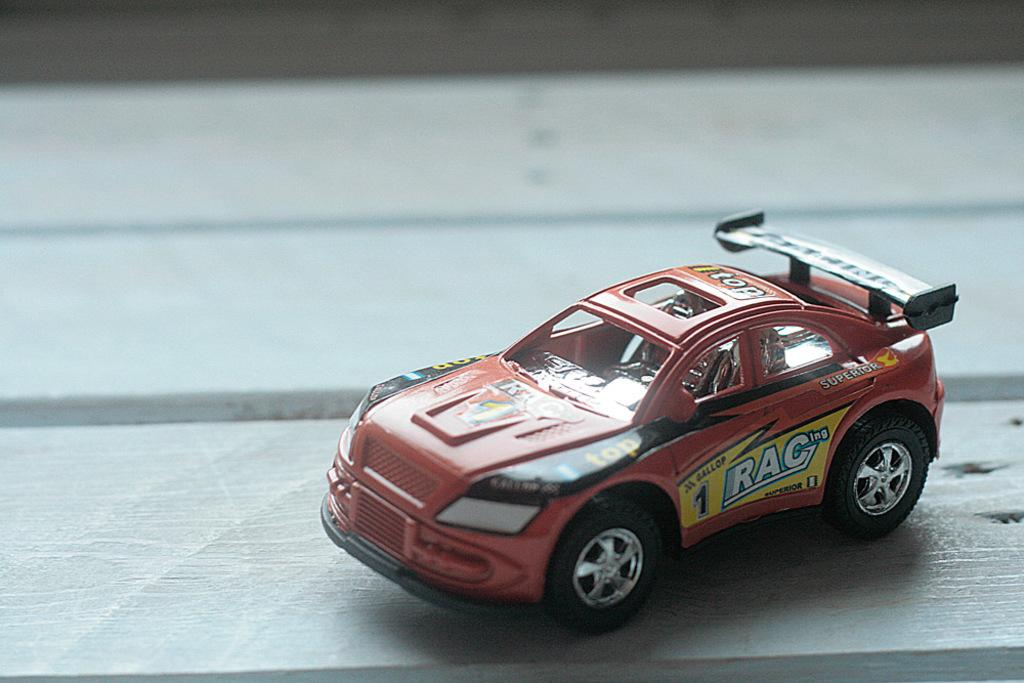What is the main object in the image? There is a table in the image. What is placed on the table? There is a toy car on the table. What type of soup is being served in the image? There is no soup present in the image; it features a table with a toy car on it. What route is the toy car following in the image? The image does not show the toy car moving or following a specific route. 